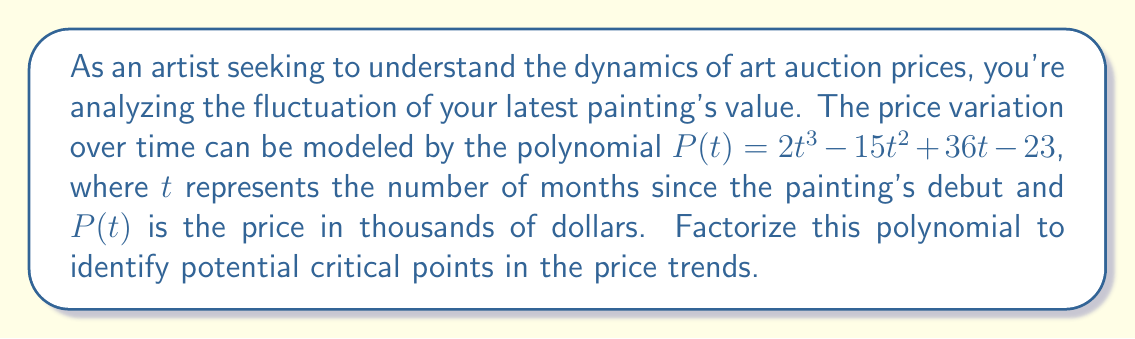Provide a solution to this math problem. To factorize the polynomial $P(t) = 2t^3 - 15t^2 + 36t - 23$, we'll follow these steps:

1) First, let's check if there's a common factor:
   There's no common factor for all terms, so we proceed.

2) This is a cubic polynomial. Let's try to find a root by guessing some factors of the constant term (-23).
   Possible factors of -23 are: ±1, ±23

3) Let's try $t = 1$:
   $P(1) = 2(1)^3 - 15(1)^2 + 36(1) - 23 = 2 - 15 + 36 - 23 = 0$

   We've found a root! So $(t-1)$ is a factor.

4) Now we can divide $P(t)$ by $(t-1)$ using polynomial long division:

   $2t^3 - 15t^2 + 36t - 23 = (t-1)(2t^2 - 13t + 23)$

5) Now we need to factor the quadratic $2t^2 - 13t + 23$. Let's use the quadratic formula:
   $t = \frac{-b \pm \sqrt{b^2 - 4ac}}{2a}$

   Here, $a=2$, $b=-13$, and $c=23$

   $t = \frac{13 \pm \sqrt{169 - 184}}{4} = \frac{13 \pm \sqrt{-15}}{4}$

   This quadratic has no real roots, so it can't be factored further over the real numbers.

6) Therefore, our final factorization is:

   $P(t) = (t-1)(2t^2 - 13t + 23)$

This factorization reveals that the polynomial has one real root at $t=1$, which could represent a critical point in the price trend one month after the painting's debut.
Answer: $P(t) = (t-1)(2t^2 - 13t + 23)$ 